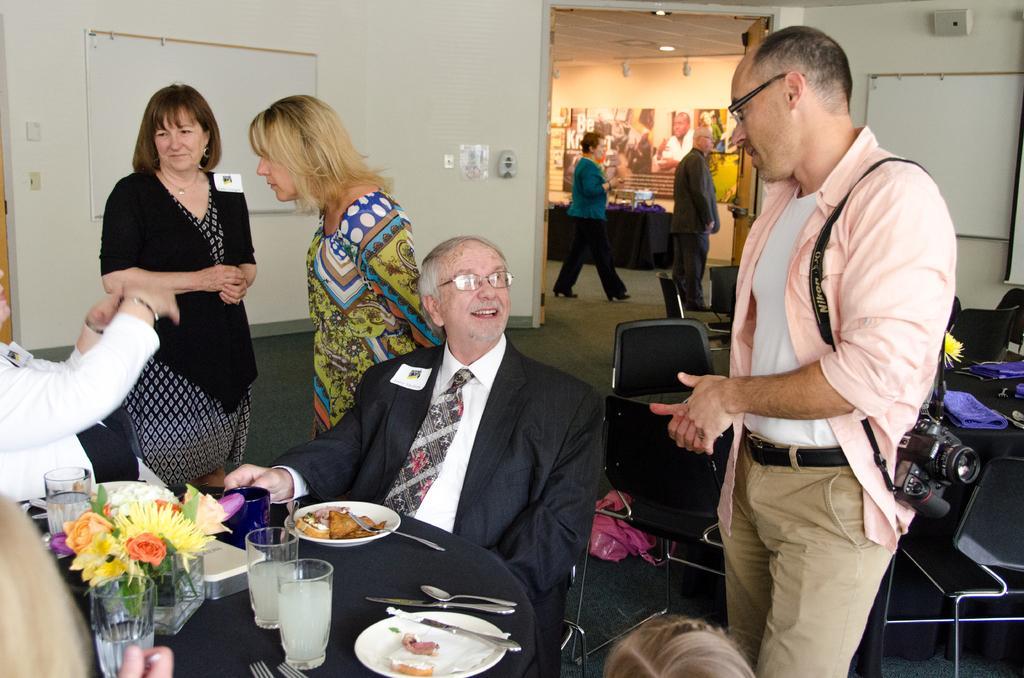Can you describe this image briefly? In the foreground of the picture we can see people, chairs, table, flower pot, flowers, glasses, food items, drinks, phone's, camera and various objects. In the middle of the picture there is a wall, projector screen and a door. In the middle of the background we can see people, table, posters and other objects. 